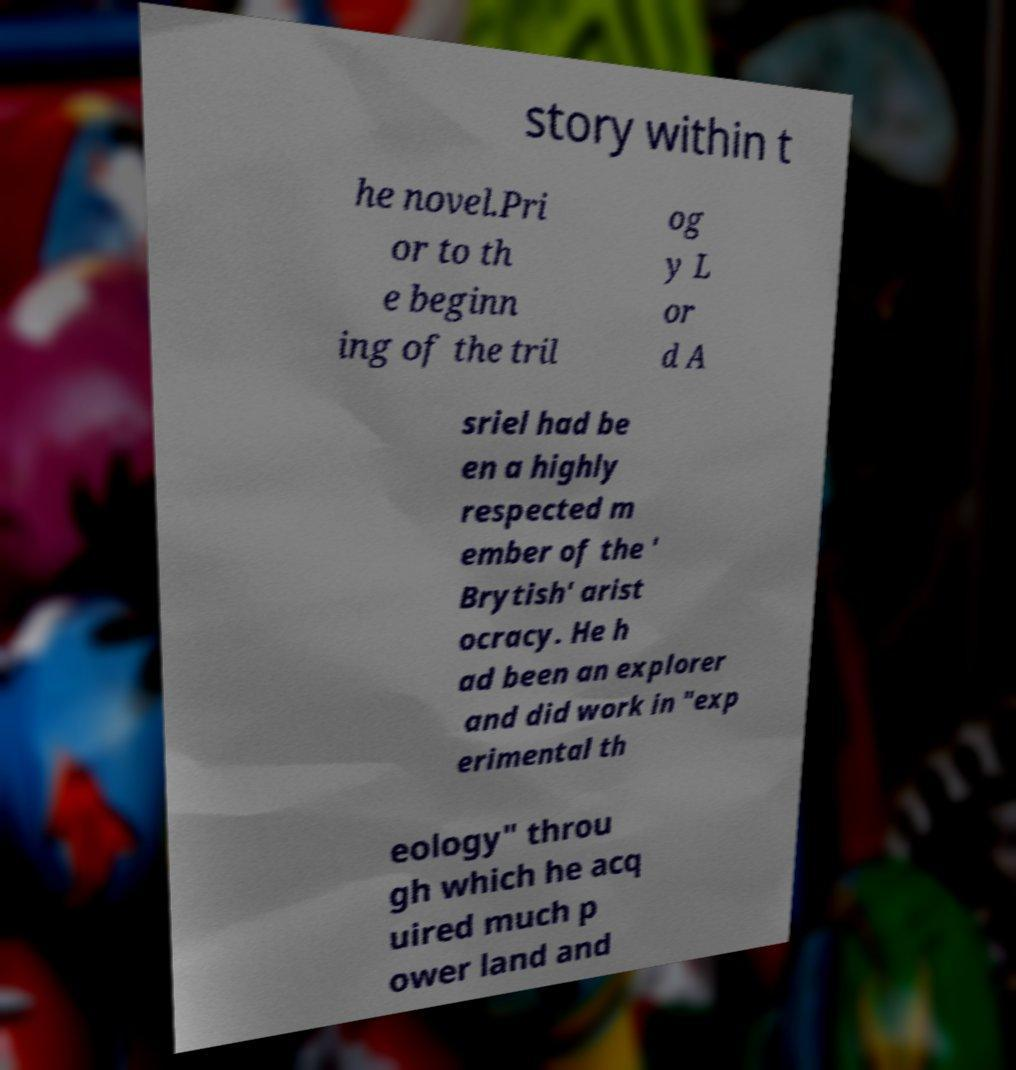Can you read and provide the text displayed in the image?This photo seems to have some interesting text. Can you extract and type it out for me? story within t he novel.Pri or to th e beginn ing of the tril og y L or d A sriel had be en a highly respected m ember of the ' Brytish' arist ocracy. He h ad been an explorer and did work in "exp erimental th eology" throu gh which he acq uired much p ower land and 